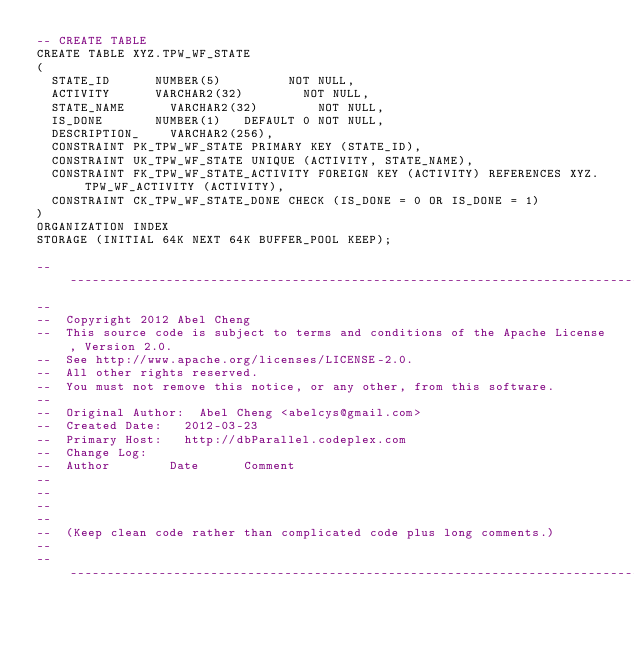Convert code to text. <code><loc_0><loc_0><loc_500><loc_500><_SQL_>-- CREATE TABLE
CREATE TABLE XYZ.TPW_WF_STATE
(
	STATE_ID			NUMBER(5)					NOT NULL,
	ACTIVITY			VARCHAR2(32)				NOT NULL,
	STATE_NAME			VARCHAR2(32)				NOT NULL,
	IS_DONE				NUMBER(1)		DEFAULT 0	NOT NULL,
	DESCRIPTION_		VARCHAR2(256),
	CONSTRAINT PK_TPW_WF_STATE PRIMARY KEY (STATE_ID),
	CONSTRAINT UK_TPW_WF_STATE UNIQUE (ACTIVITY, STATE_NAME),
	CONSTRAINT FK_TPW_WF_STATE_ACTIVITY FOREIGN KEY (ACTIVITY) REFERENCES XYZ.TPW_WF_ACTIVITY (ACTIVITY),
	CONSTRAINT CK_TPW_WF_STATE_DONE CHECK (IS_DONE = 0 OR IS_DONE = 1)
)
ORGANIZATION INDEX
STORAGE (INITIAL 64K NEXT 64K BUFFER_POOL KEEP);

----------------------------------------------------------------------------------------------------
--
--	Copyright 2012 Abel Cheng
--	This source code is subject to terms and conditions of the Apache License, Version 2.0.
--	See http://www.apache.org/licenses/LICENSE-2.0.
--	All other rights reserved.
--	You must not remove this notice, or any other, from this software.
--
--	Original Author:	Abel Cheng <abelcys@gmail.com>
--	Created Date:		2012-03-23
--	Primary Host:		http://dbParallel.codeplex.com
--	Change Log:
--	Author				Date			Comment
--
--
--
--
--	(Keep clean code rather than complicated code plus long comments.)
--
----------------------------------------------------------------------------------------------------
</code> 